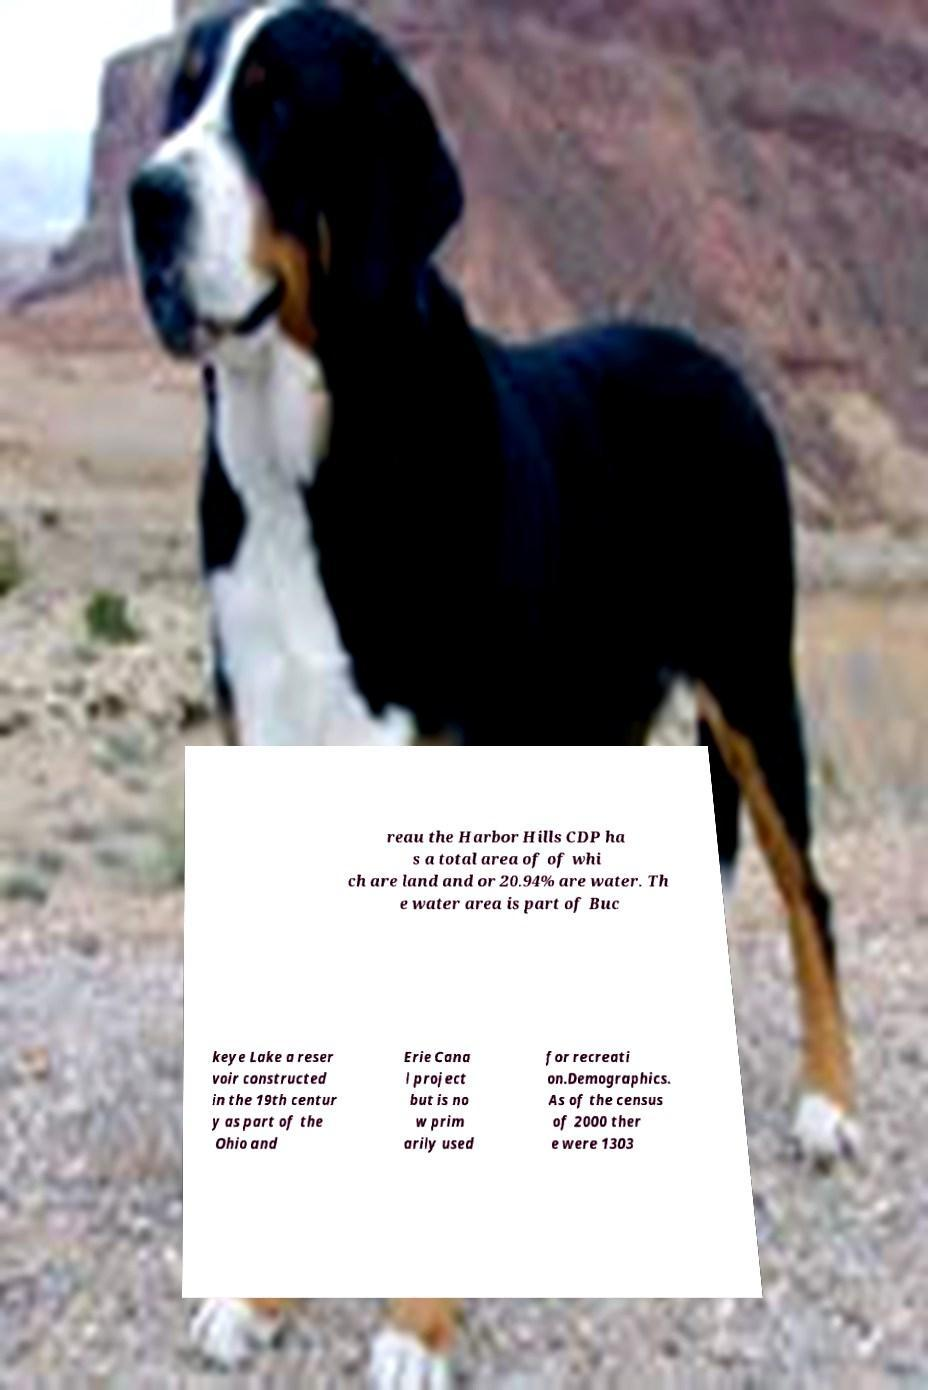Could you extract and type out the text from this image? reau the Harbor Hills CDP ha s a total area of of whi ch are land and or 20.94% are water. Th e water area is part of Buc keye Lake a reser voir constructed in the 19th centur y as part of the Ohio and Erie Cana l project but is no w prim arily used for recreati on.Demographics. As of the census of 2000 ther e were 1303 